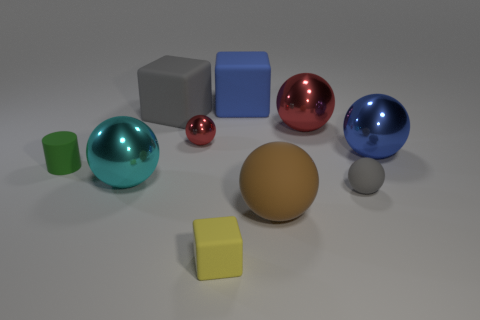Subtract all small blocks. How many blocks are left? 2 Subtract all tiny cyan matte blocks. Subtract all tiny yellow blocks. How many objects are left? 9 Add 3 gray objects. How many gray objects are left? 5 Add 8 large red matte cubes. How many large red matte cubes exist? 8 Subtract all cyan spheres. How many spheres are left? 5 Subtract 0 yellow spheres. How many objects are left? 10 Subtract all cylinders. How many objects are left? 9 Subtract 3 blocks. How many blocks are left? 0 Subtract all green balls. Subtract all yellow cubes. How many balls are left? 6 Subtract all gray cubes. How many purple cylinders are left? 0 